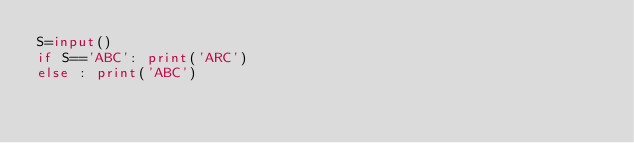<code> <loc_0><loc_0><loc_500><loc_500><_Python_>S=input()
if S=='ABC': print('ARC')
else : print('ABC')</code> 